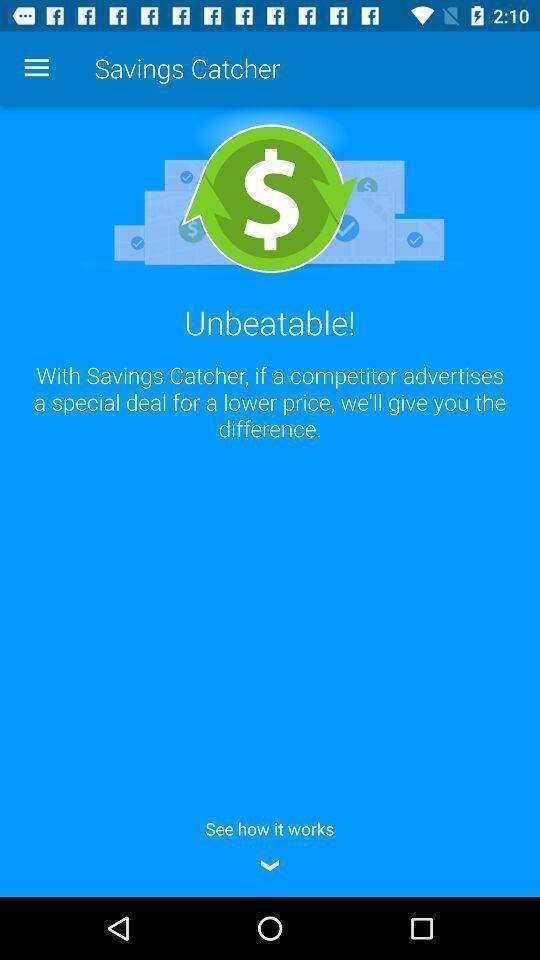Describe the visual elements of this screenshot. Page showing message for walmart savings. 